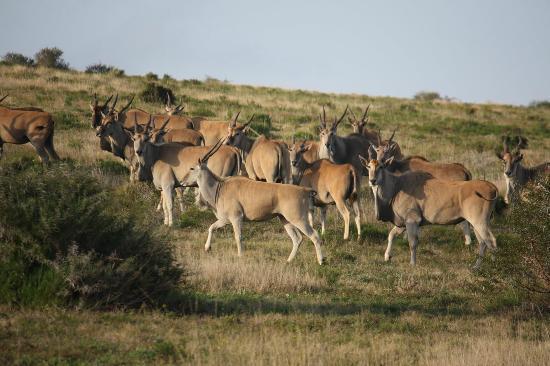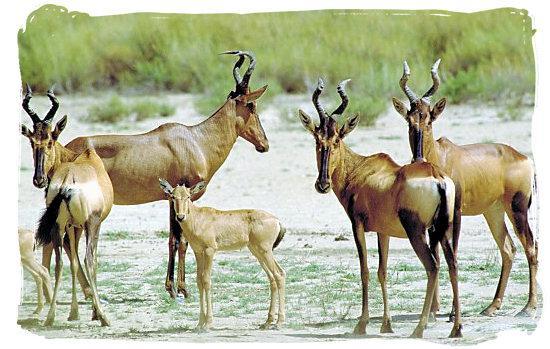The first image is the image on the left, the second image is the image on the right. Examine the images to the left and right. Is the description "An image shows a group of five antelope type animals." accurate? Answer yes or no. Yes. The first image is the image on the left, the second image is the image on the right. Examine the images to the left and right. Is the description "There are 5 antelopes in the right most image." accurate? Answer yes or no. Yes. 